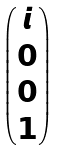<formula> <loc_0><loc_0><loc_500><loc_500>\begin{pmatrix} i \\ 0 \\ 0 \\ 1 \end{pmatrix}</formula> 